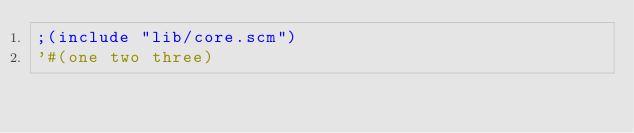<code> <loc_0><loc_0><loc_500><loc_500><_Scheme_>;(include "lib/core.scm")
'#(one two three)
</code> 